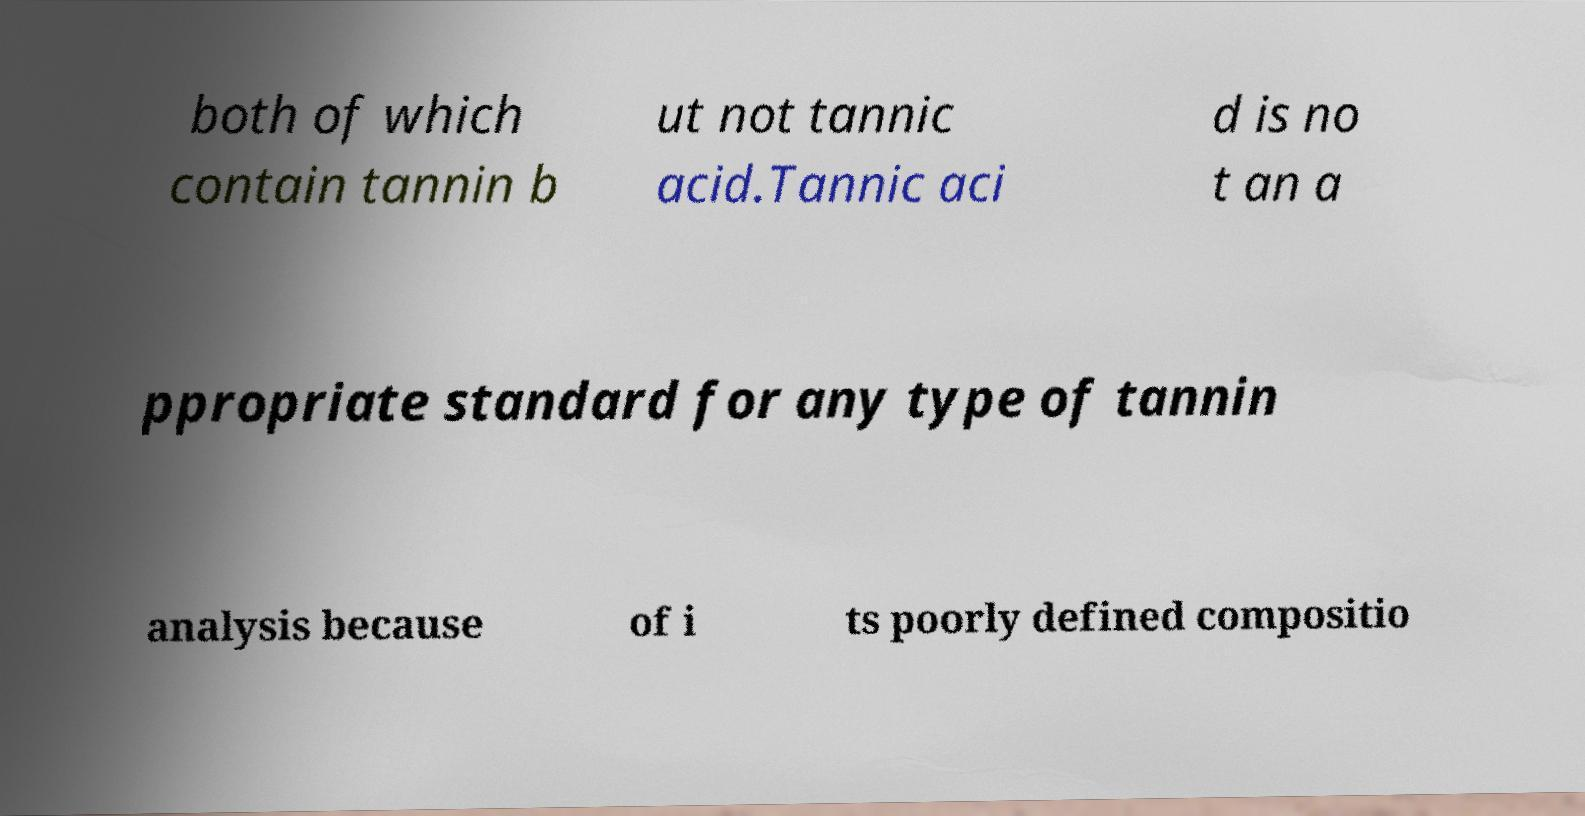Please read and relay the text visible in this image. What does it say? both of which contain tannin b ut not tannic acid.Tannic aci d is no t an a ppropriate standard for any type of tannin analysis because of i ts poorly defined compositio 